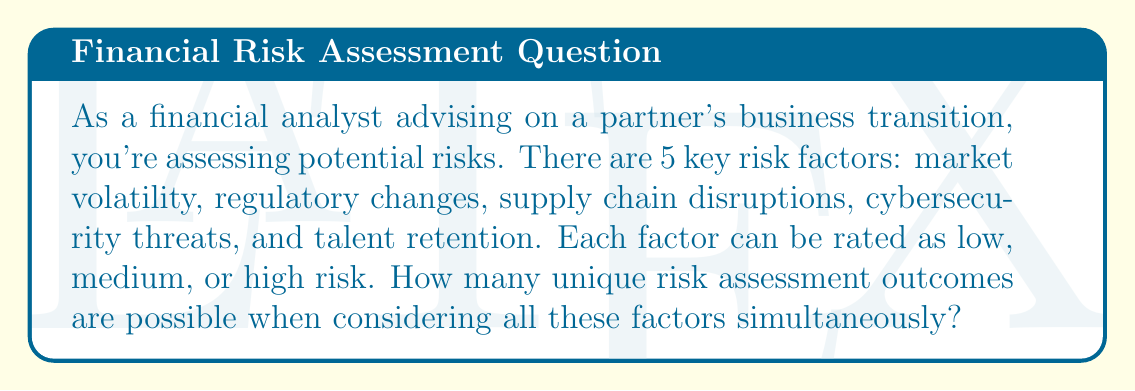Help me with this question. To solve this problem, we'll use the multiplication principle from combinatorics. Here's the step-by-step solution:

1) We have 5 risk factors: market volatility, regulatory changes, supply chain disruptions, cybersecurity threats, and talent retention.

2) Each factor can be rated in 3 ways: low, medium, or high risk.

3) For each factor, we have 3 choices, and this is true for all 5 factors.

4) According to the multiplication principle, if we have a series of independent choices, the total number of outcomes is the product of the number of possibilities for each choice.

5) Therefore, the total number of unique risk assessment outcomes is:

   $$3 \times 3 \times 3 \times 3 \times 3 = 3^5$$

6) Calculate $3^5$:
   $$3^5 = 3 \times 3 \times 3 \times 3 \times 3 = 243$$

Thus, there are 243 unique risk assessment outcomes possible.
Answer: 243 